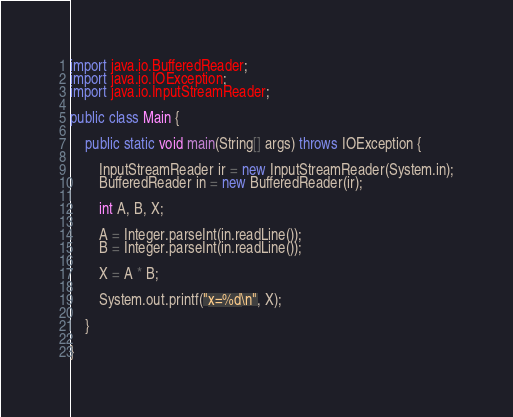<code> <loc_0><loc_0><loc_500><loc_500><_Java_>import java.io.BufferedReader;
import java.io.IOException;
import java.io.InputStreamReader;

public class Main {
    
    public static void main(String[] args) throws IOException {
        
        InputStreamReader ir = new InputStreamReader(System.in);
        BufferedReader in = new BufferedReader(ir);
        
        int A, B, X;
        
        A = Integer.parseInt(in.readLine());
        B = Integer.parseInt(in.readLine());
        
        X = A * B;
        
        System.out.printf("x=%d\n", X);
        
    }
    
}</code> 